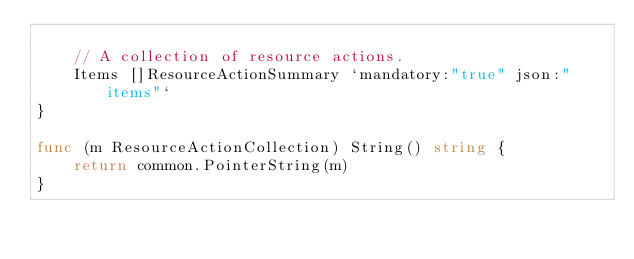<code> <loc_0><loc_0><loc_500><loc_500><_Go_>
	// A collection of resource actions.
	Items []ResourceActionSummary `mandatory:"true" json:"items"`
}

func (m ResourceActionCollection) String() string {
	return common.PointerString(m)
}
</code> 